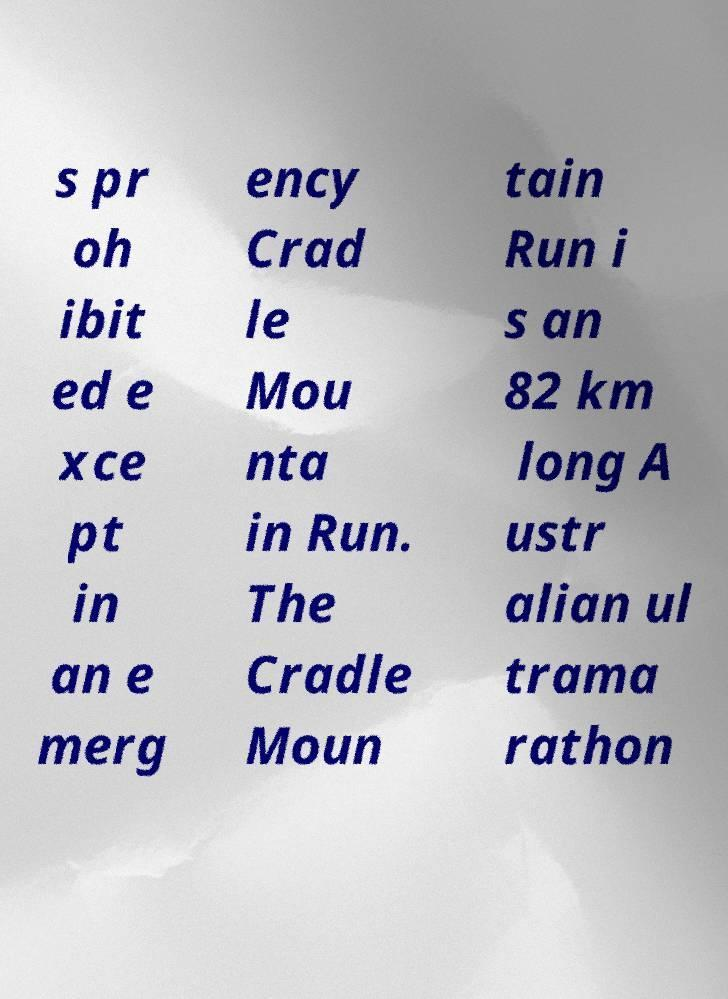There's text embedded in this image that I need extracted. Can you transcribe it verbatim? s pr oh ibit ed e xce pt in an e merg ency Crad le Mou nta in Run. The Cradle Moun tain Run i s an 82 km long A ustr alian ul trama rathon 